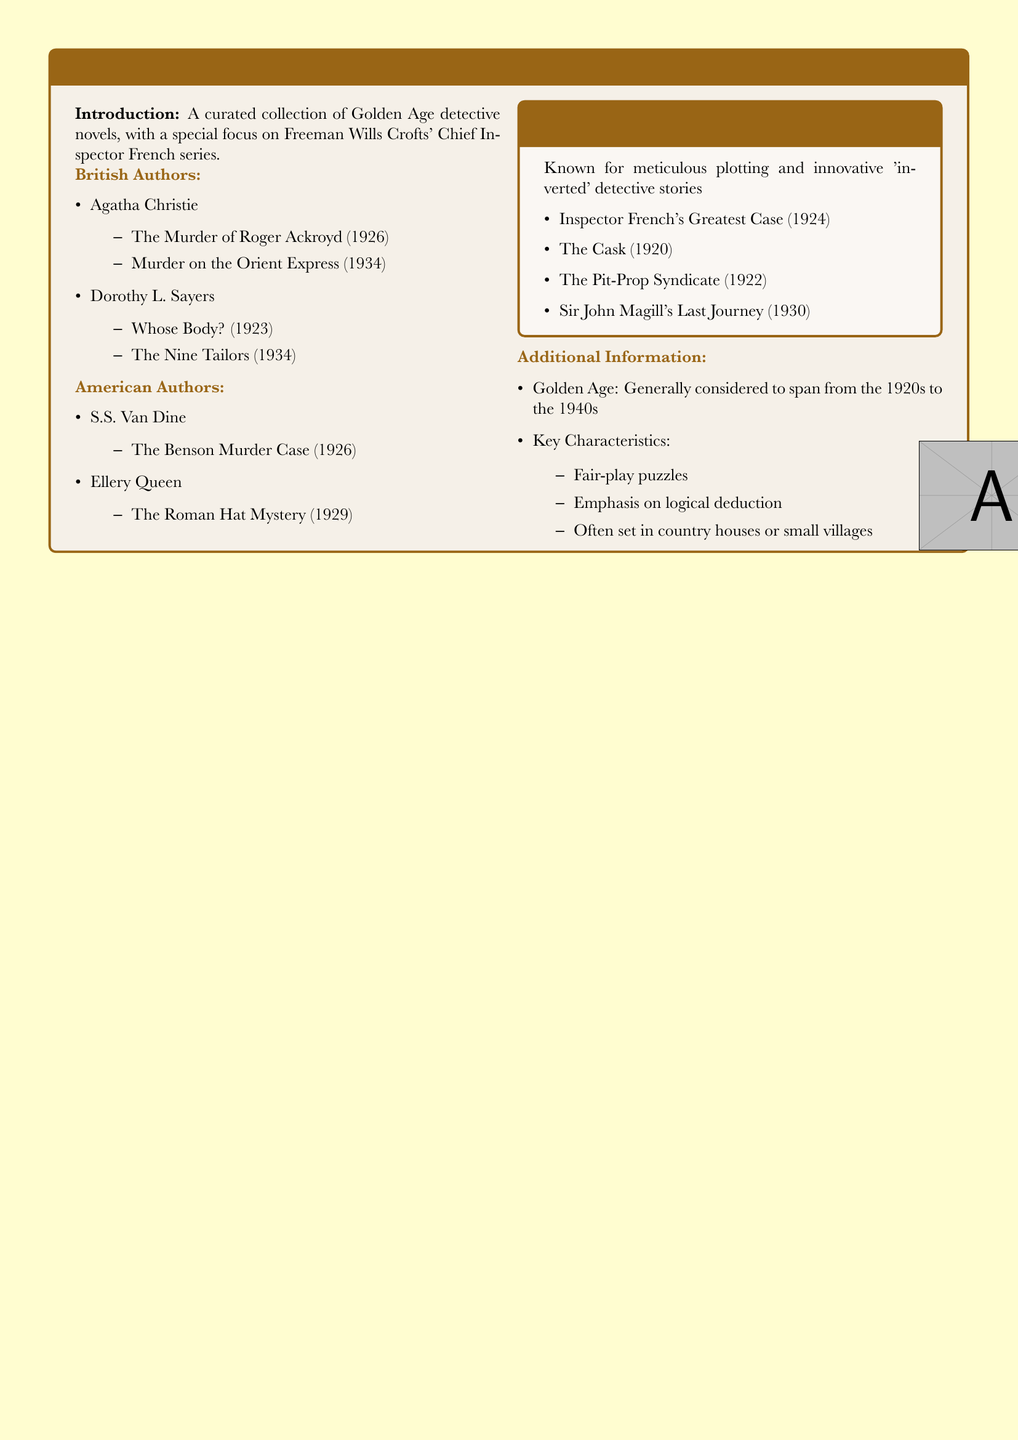What is the title of a novel by Agatha Christie published in 1934? The document lists "Murder on the Orient Express" published in 1934.
Answer: Murder on the Orient Express Which author wrote "Whose Body?"? The document states that "Whose Body?" is written by Dorothy L. Sayers.
Answer: Dorothy L. Sayers What year was "The Cask" published? According to the document, "The Cask" was published in 1920.
Answer: 1920 Name a title from Freeman Wills Crofts' Chief Inspector French series. The document lists several titles, including "Inspector French's Greatest Case."
Answer: Inspector French's Greatest Case How many novels are listed under British authors? The document includes four novels under British authors.
Answer: 4 Which section details Freeman Wills Crofts' work? The document features a specific section labeled "Freeman Wills Crofts' Chief Inspector French Series."
Answer: Freeman Wills Crofts' Chief Inspector French Series What is a key characteristic of Golden Age detective fiction? The document lists "Fair-play puzzles" as a key characteristic.
Answer: Fair-play puzzles What time period is generally considered the Golden Age of detective fiction? The document states that the Golden Age generally spans from the 1920s to the 1940s.
Answer: 1920s to the 1940s Who is known for meticulous plotting in detective novels? The document attributes meticulous plotting to Freeman Wills Crofts.
Answer: Freeman Wills Crofts 